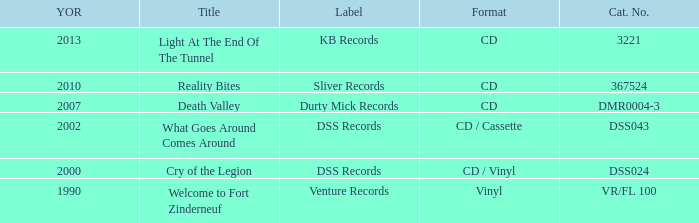What is the latest year of the album with the release title death valley? 2007.0. 